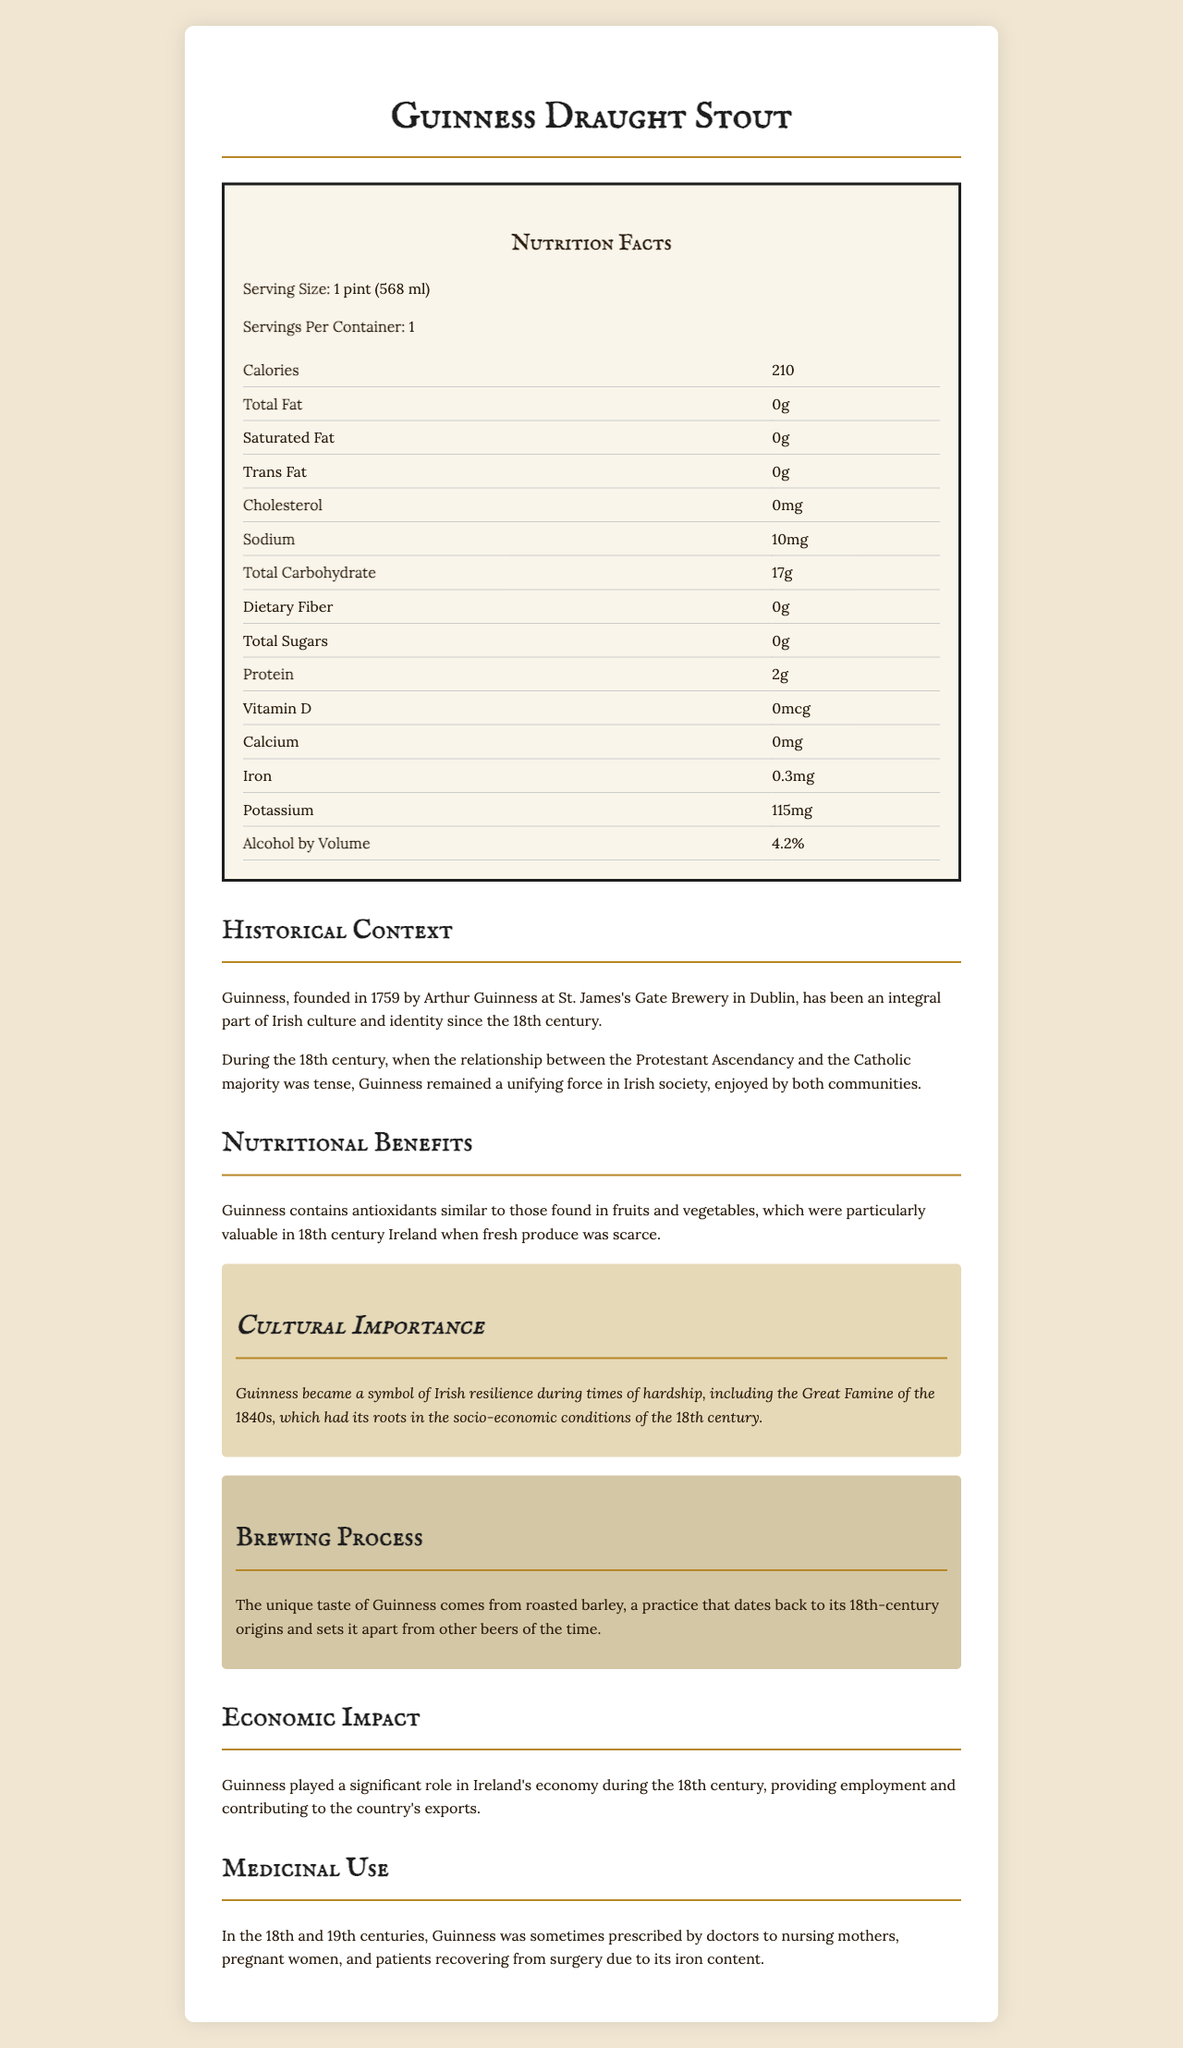What is the serving size of Guinness Draught Stout? The serving size is explicitly mentioned in the Nutrition Facts section of the document.
Answer: 1 pint (568 ml) How many calories does one serving of Guinness Draught Stout contain? The document lists 210 calories in one serving in the Nutrition Facts section.
Answer: 210 What is the total carbohydrate content in one serving of Guinness Draught Stout? According to the Nutrition Facts section, the total carbohydrate content is 17 grams.
Answer: 17 grams What is the alcohol by volume (ABV) percentage of Guinness Draught Stout? The ABV percentage is listed under the Nutrition Facts table as 4.2%.
Answer: 4.2% How much iron is in one serving of Guinness Draught Stout? The amount of iron is listed as 0.3 mg in the Nutrition Facts section.
Answer: 0.3 mg Does Guinness Draught Stout contain any cholesterol? The Nutrition Facts list the cholesterol content as 0 mg, indicating there is no cholesterol.
Answer: No What historical figure founded Guinness, and in what year? A. Arthur Guinness in 1725 B. Arthur Guinness in 1759 C. John Jameson in 1780 D. William Smith in 1800 The document states that Guinness was founded by Arthur Guinness in 1759 at St. James's Gate Brewery in Dublin.
Answer: B Which of the following is not mentioned as a component of Guinness Draught Stout's brewing process? A. Roasted barley B. Hops C. Yeast The document specifics that roasted barley contributes to the unique taste of Guinness, but does not mention hops in the brewing process section.
Answer: B Is it true that Guinness Draught Stout was sometimes prescribed by doctors to nursing mothers and pregnant women in the 18th and 19th centuries? The document states that Guinness was sometimes prescribed by doctors to nursing mothers, pregnant women, and patients recovering from surgery due to its iron content.
Answer: Yes Summarize the cultural and historical significance of Guinness Draught Stout described in the document. The document positions Guinness Draught Stout as more than just a beverage; it’s a symbol of Irish identity and perseverance. It unified communities during periods of religious strife and continues to be associated with Irish culture. The unique taste results from historical brewing methods, and its economic impact has been substantial since its inception.
Answer: Guinness Draught Stout holds a vital place in Irish culture and history. Founded by Arthur Guinness in 1759, it has played a unifying role in Irish society through times of religious tension in the 18th century. It symbolizes Irish resilience, particularly during hardships like the Great Famine. Its brewing process involves roasted barley, creating a distinct taste that has been appreciated for centuries. Economically, it has contributed significantly to Ireland by providing jobs and boosting exports. Additionally, it contains antioxidants and was even prescribed for its iron content. How does the caloric content of Guinness Draught Stout compare to other stouts? The document only provides the nutritional information for Guinness Draught Stout, not for other stouts, so a comparison cannot be made.
Answer: Cannot be determined 